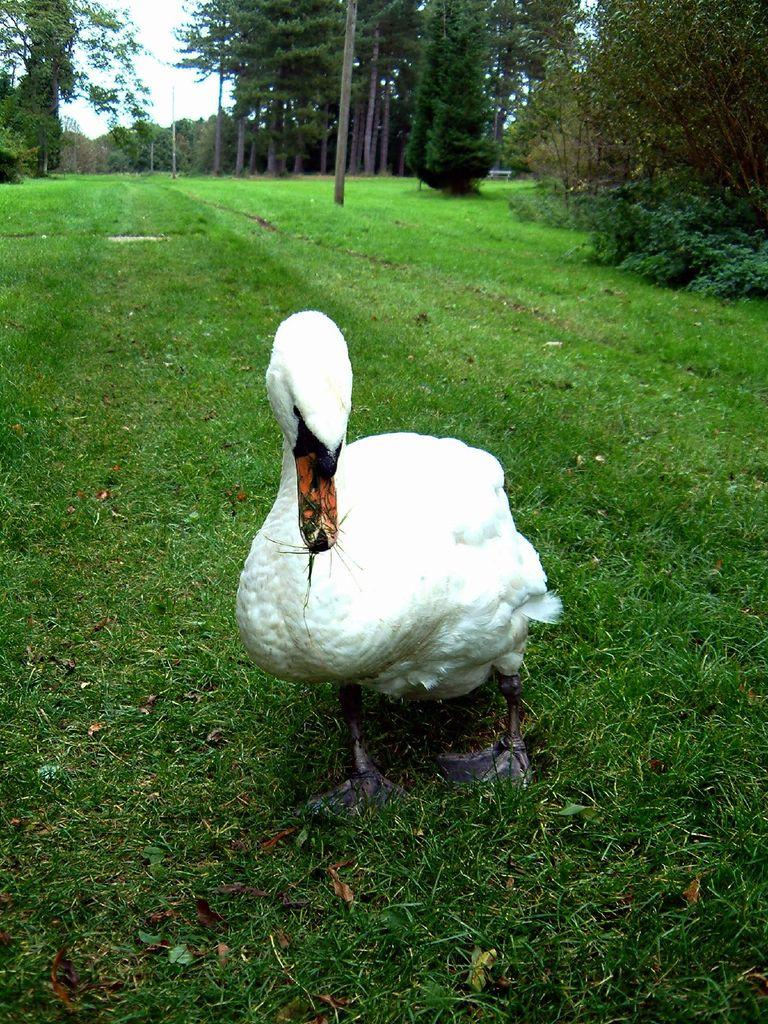What animal is in the center of the image? There is a duck in the center of the image. What type of vegetation is at the bottom of the image? There is grass at the bottom of the image. What can be seen in the background of the image? There are trees and the sky visible in the background of the image. How many snails are crawling on the stick in the image? There is no stick or snails present in the image. 